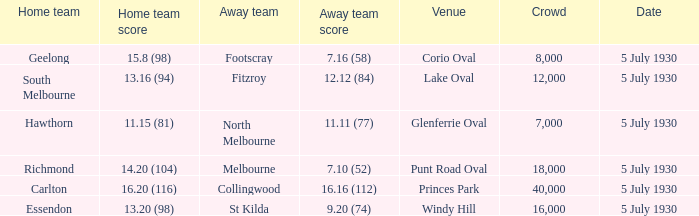What day does the team play at punt road oval? 5 July 1930. 